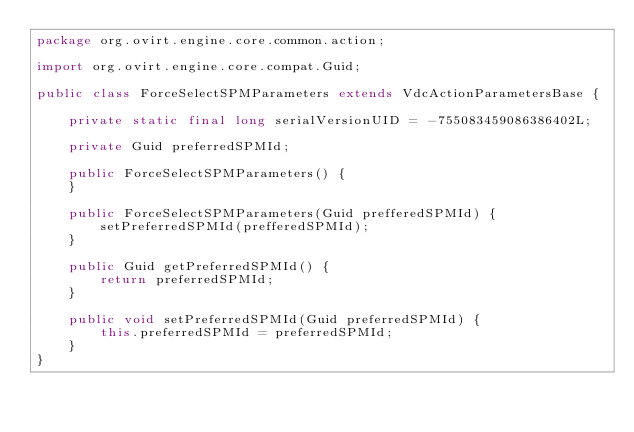<code> <loc_0><loc_0><loc_500><loc_500><_Java_>package org.ovirt.engine.core.common.action;

import org.ovirt.engine.core.compat.Guid;

public class ForceSelectSPMParameters extends VdcActionParametersBase {

    private static final long serialVersionUID = -755083459086386402L;

    private Guid preferredSPMId;

    public ForceSelectSPMParameters() {
    }

    public ForceSelectSPMParameters(Guid prefferedSPMId) {
        setPreferredSPMId(prefferedSPMId);
    }

    public Guid getPreferredSPMId() {
        return preferredSPMId;
    }

    public void setPreferredSPMId(Guid preferredSPMId) {
        this.preferredSPMId = preferredSPMId;
    }
}
</code> 